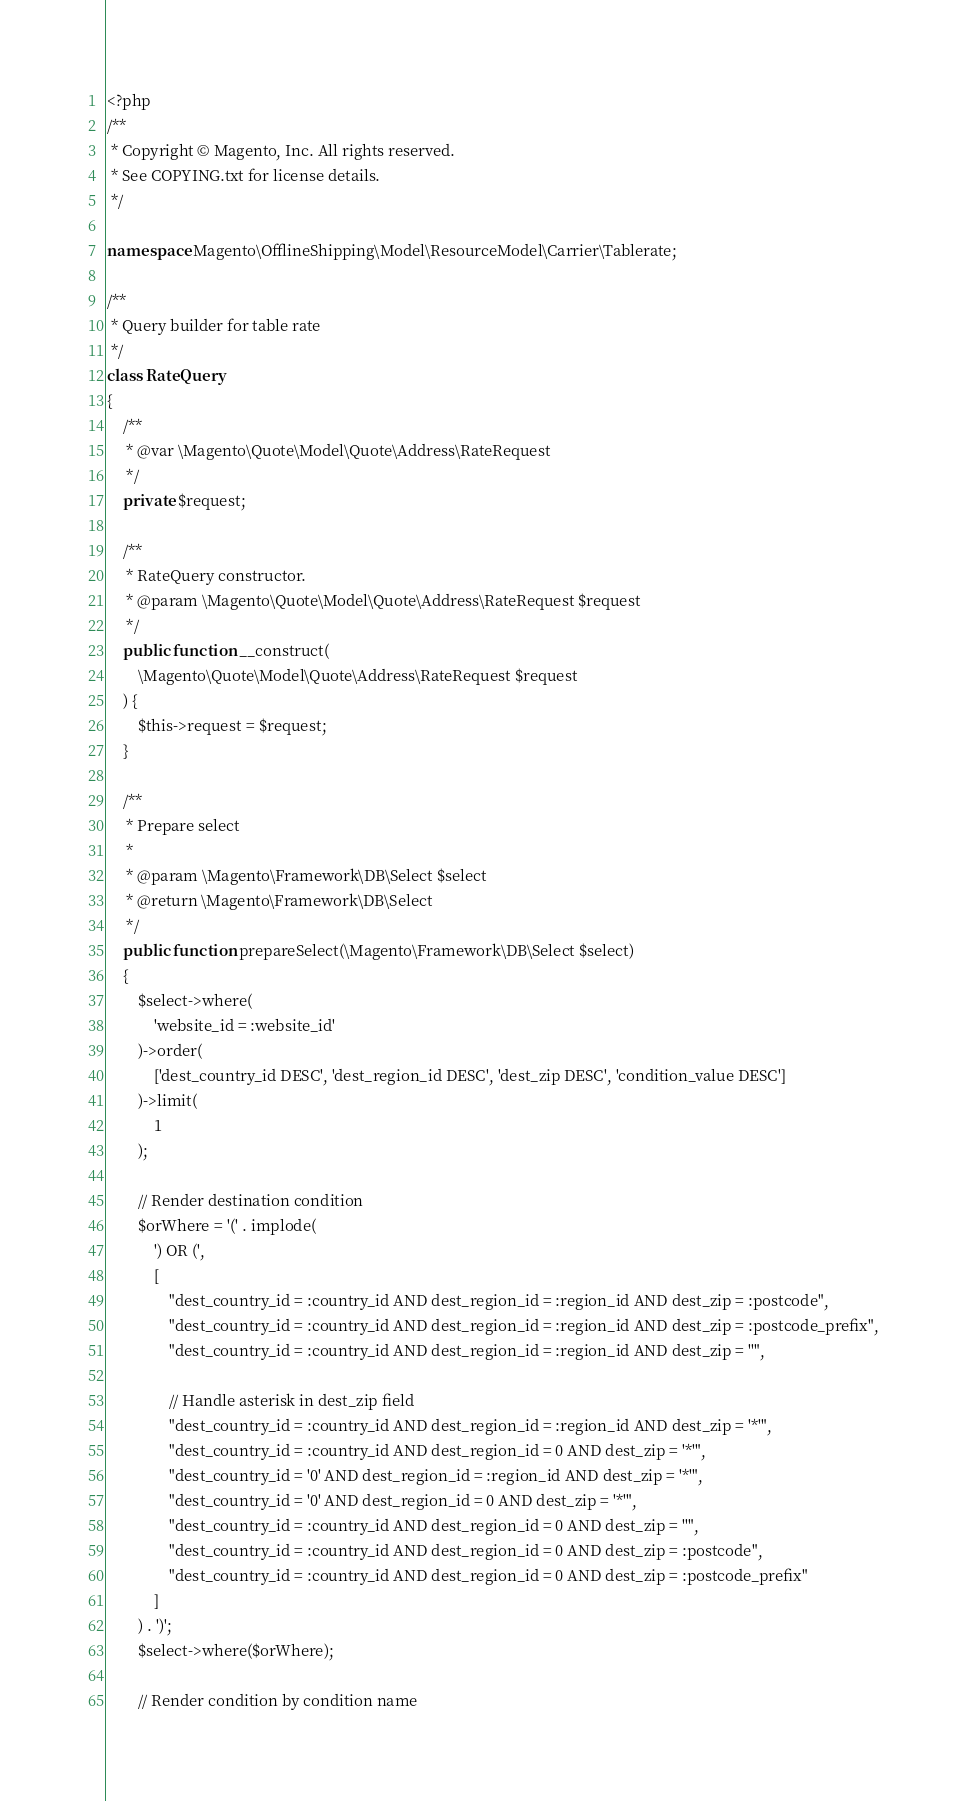<code> <loc_0><loc_0><loc_500><loc_500><_PHP_><?php
/**
 * Copyright © Magento, Inc. All rights reserved.
 * See COPYING.txt for license details.
 */

namespace Magento\OfflineShipping\Model\ResourceModel\Carrier\Tablerate;

/**
 * Query builder for table rate
 */
class RateQuery
{
    /**
     * @var \Magento\Quote\Model\Quote\Address\RateRequest
     */
    private $request;

    /**
     * RateQuery constructor.
     * @param \Magento\Quote\Model\Quote\Address\RateRequest $request
     */
    public function __construct(
        \Magento\Quote\Model\Quote\Address\RateRequest $request
    ) {
        $this->request = $request;
    }

    /**
     * Prepare select
     *
     * @param \Magento\Framework\DB\Select $select
     * @return \Magento\Framework\DB\Select
     */
    public function prepareSelect(\Magento\Framework\DB\Select $select)
    {
        $select->where(
            'website_id = :website_id'
        )->order(
            ['dest_country_id DESC', 'dest_region_id DESC', 'dest_zip DESC', 'condition_value DESC']
        )->limit(
            1
        );

        // Render destination condition
        $orWhere = '(' . implode(
            ') OR (',
            [
                "dest_country_id = :country_id AND dest_region_id = :region_id AND dest_zip = :postcode",
                "dest_country_id = :country_id AND dest_region_id = :region_id AND dest_zip = :postcode_prefix",
                "dest_country_id = :country_id AND dest_region_id = :region_id AND dest_zip = ''",

                // Handle asterisk in dest_zip field
                "dest_country_id = :country_id AND dest_region_id = :region_id AND dest_zip = '*'",
                "dest_country_id = :country_id AND dest_region_id = 0 AND dest_zip = '*'",
                "dest_country_id = '0' AND dest_region_id = :region_id AND dest_zip = '*'",
                "dest_country_id = '0' AND dest_region_id = 0 AND dest_zip = '*'",
                "dest_country_id = :country_id AND dest_region_id = 0 AND dest_zip = ''",
                "dest_country_id = :country_id AND dest_region_id = 0 AND dest_zip = :postcode",
                "dest_country_id = :country_id AND dest_region_id = 0 AND dest_zip = :postcode_prefix"
            ]
        ) . ')';
        $select->where($orWhere);

        // Render condition by condition name</code> 